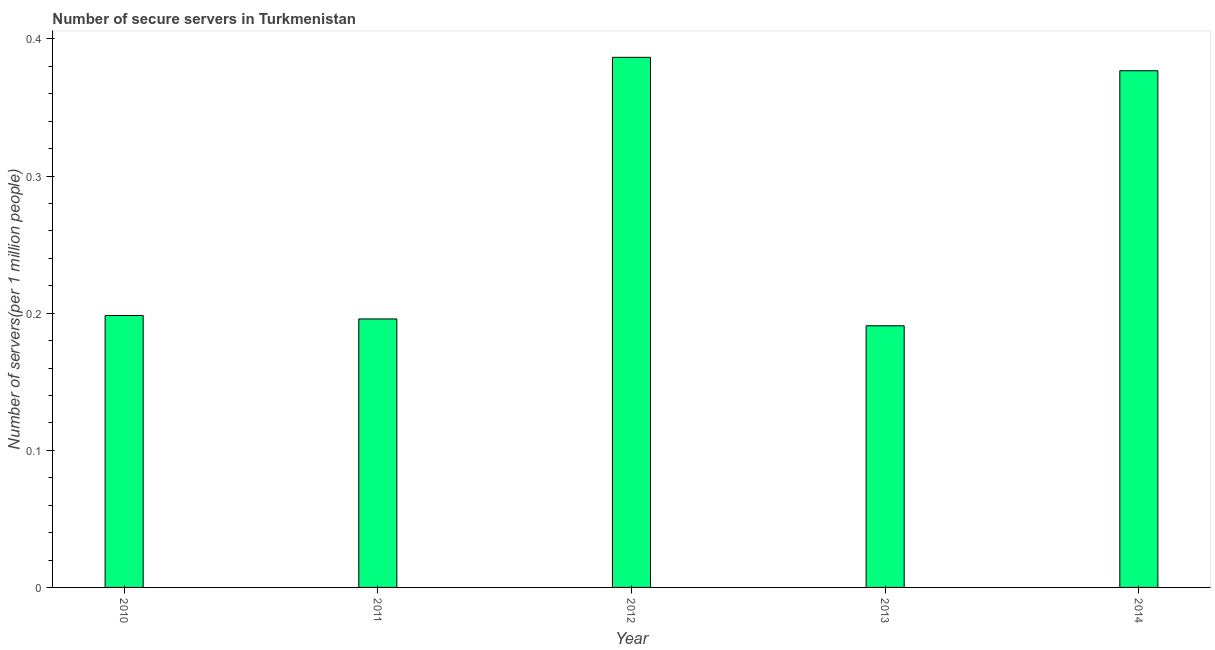Does the graph contain grids?
Your answer should be very brief. No. What is the title of the graph?
Your answer should be compact. Number of secure servers in Turkmenistan. What is the label or title of the Y-axis?
Provide a short and direct response. Number of servers(per 1 million people). What is the number of secure internet servers in 2012?
Keep it short and to the point. 0.39. Across all years, what is the maximum number of secure internet servers?
Your answer should be very brief. 0.39. Across all years, what is the minimum number of secure internet servers?
Offer a terse response. 0.19. What is the sum of the number of secure internet servers?
Ensure brevity in your answer.  1.35. What is the difference between the number of secure internet servers in 2011 and 2013?
Offer a terse response. 0.01. What is the average number of secure internet servers per year?
Provide a succinct answer. 0.27. What is the median number of secure internet servers?
Provide a short and direct response. 0.2. In how many years, is the number of secure internet servers greater than 0.06 ?
Offer a very short reply. 5. What is the ratio of the number of secure internet servers in 2010 to that in 2011?
Give a very brief answer. 1.01. Is the difference between the number of secure internet servers in 2011 and 2013 greater than the difference between any two years?
Ensure brevity in your answer.  No. What is the difference between the highest and the second highest number of secure internet servers?
Offer a very short reply. 0.01. How many bars are there?
Provide a succinct answer. 5. How many years are there in the graph?
Offer a very short reply. 5. What is the Number of servers(per 1 million people) in 2010?
Offer a terse response. 0.2. What is the Number of servers(per 1 million people) of 2011?
Give a very brief answer. 0.2. What is the Number of servers(per 1 million people) of 2012?
Your answer should be compact. 0.39. What is the Number of servers(per 1 million people) of 2013?
Your answer should be compact. 0.19. What is the Number of servers(per 1 million people) of 2014?
Provide a succinct answer. 0.38. What is the difference between the Number of servers(per 1 million people) in 2010 and 2011?
Provide a short and direct response. 0. What is the difference between the Number of servers(per 1 million people) in 2010 and 2012?
Provide a succinct answer. -0.19. What is the difference between the Number of servers(per 1 million people) in 2010 and 2013?
Provide a short and direct response. 0.01. What is the difference between the Number of servers(per 1 million people) in 2010 and 2014?
Offer a terse response. -0.18. What is the difference between the Number of servers(per 1 million people) in 2011 and 2012?
Ensure brevity in your answer.  -0.19. What is the difference between the Number of servers(per 1 million people) in 2011 and 2013?
Ensure brevity in your answer.  0. What is the difference between the Number of servers(per 1 million people) in 2011 and 2014?
Provide a short and direct response. -0.18. What is the difference between the Number of servers(per 1 million people) in 2012 and 2013?
Give a very brief answer. 0.2. What is the difference between the Number of servers(per 1 million people) in 2012 and 2014?
Provide a succinct answer. 0.01. What is the difference between the Number of servers(per 1 million people) in 2013 and 2014?
Provide a short and direct response. -0.19. What is the ratio of the Number of servers(per 1 million people) in 2010 to that in 2011?
Your answer should be very brief. 1.01. What is the ratio of the Number of servers(per 1 million people) in 2010 to that in 2012?
Your answer should be compact. 0.51. What is the ratio of the Number of servers(per 1 million people) in 2010 to that in 2013?
Your answer should be very brief. 1.04. What is the ratio of the Number of servers(per 1 million people) in 2010 to that in 2014?
Give a very brief answer. 0.53. What is the ratio of the Number of servers(per 1 million people) in 2011 to that in 2012?
Keep it short and to the point. 0.51. What is the ratio of the Number of servers(per 1 million people) in 2011 to that in 2014?
Give a very brief answer. 0.52. What is the ratio of the Number of servers(per 1 million people) in 2012 to that in 2013?
Your response must be concise. 2.03. What is the ratio of the Number of servers(per 1 million people) in 2012 to that in 2014?
Your answer should be very brief. 1.03. What is the ratio of the Number of servers(per 1 million people) in 2013 to that in 2014?
Keep it short and to the point. 0.51. 